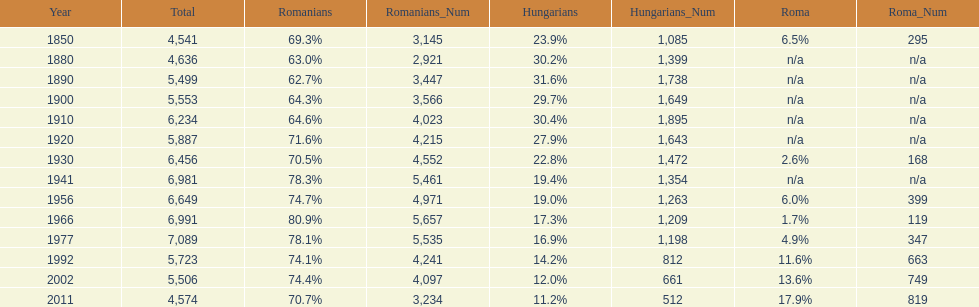Could you parse the entire table as a dict? {'header': ['Year', 'Total', 'Romanians', 'Romanians_Num', 'Hungarians', 'Hungarians_Num', 'Roma', 'Roma_Num'], 'rows': [['1850', '4,541', '69.3%', '3,145', '23.9%', '1,085', '6.5%', '295'], ['1880', '4,636', '63.0%', '2,921', '30.2%', '1,399', 'n/a', 'n/a'], ['1890', '5,499', '62.7%', '3,447', '31.6%', '1,738', 'n/a', 'n/a'], ['1900', '5,553', '64.3%', '3,566', '29.7%', '1,649', 'n/a', 'n/a'], ['1910', '6,234', '64.6%', '4,023', '30.4%', '1,895', 'n/a', 'n/a'], ['1920', '5,887', '71.6%', '4,215', '27.9%', '1,643', 'n/a', 'n/a'], ['1930', '6,456', '70.5%', '4,552', '22.8%', '1,472', '2.6%', '168'], ['1941', '6,981', '78.3%', '5,461', '19.4%', '1,354', 'n/a', 'n/a'], ['1956', '6,649', '74.7%', '4,971', '19.0%', '1,263', '6.0%', '399'], ['1966', '6,991', '80.9%', '5,657', '17.3%', '1,209', '1.7%', '119'], ['1977', '7,089', '78.1%', '5,535', '16.9%', '1,198', '4.9%', '347'], ['1992', '5,723', '74.1%', '4,241', '14.2%', '812', '11.6%', '663'], ['2002', '5,506', '74.4%', '4,097', '12.0%', '661', '13.6%', '749'], ['2011', '4,574', '70.7%', '3,234', '11.2%', '512', '17.9%', '819']]} What year had the highest total number? 1977. 